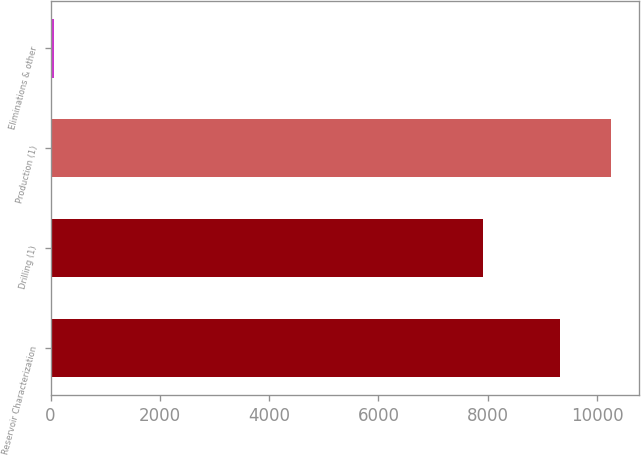Convert chart to OTSL. <chart><loc_0><loc_0><loc_500><loc_500><bar_chart><fcel>Reservoir Characterization<fcel>Drilling (1)<fcel>Production (1)<fcel>Eliminations & other<nl><fcel>9321<fcel>7917<fcel>10250.8<fcel>68<nl></chart> 